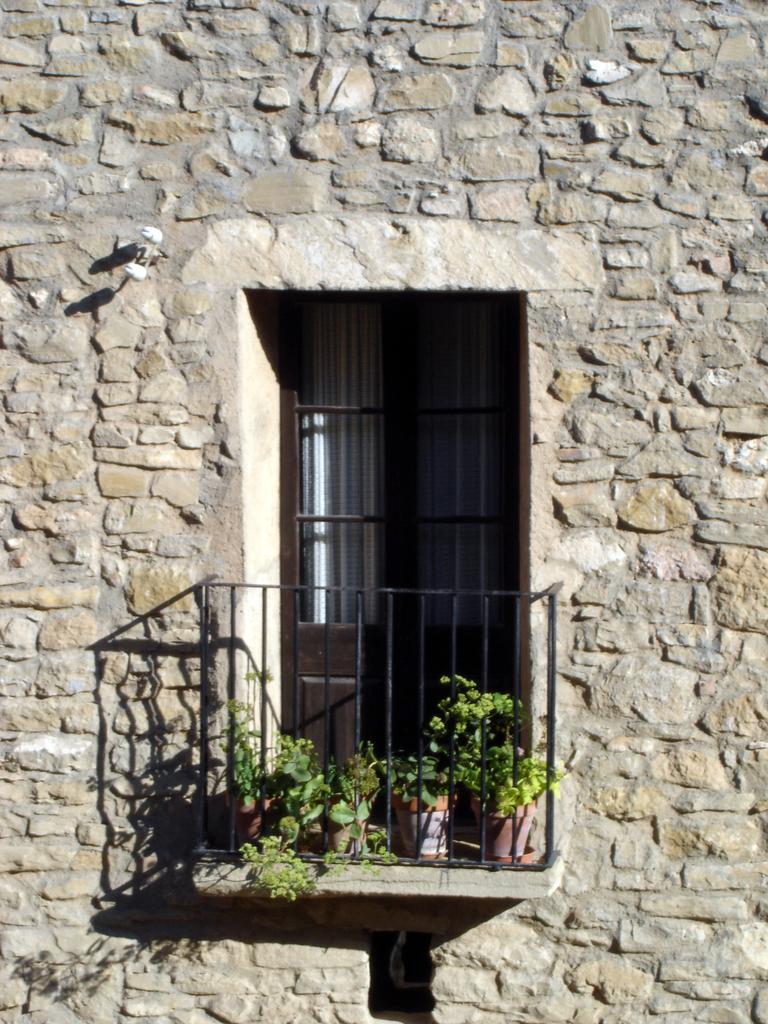How would you summarize this image in a sentence or two? In this image I can see the building which is made up of stones which is ash, cream and brown in color. I can see the door which is brown in color, the curtain, few flower pots, few trees which are green in color and I can see the black colored railing. 